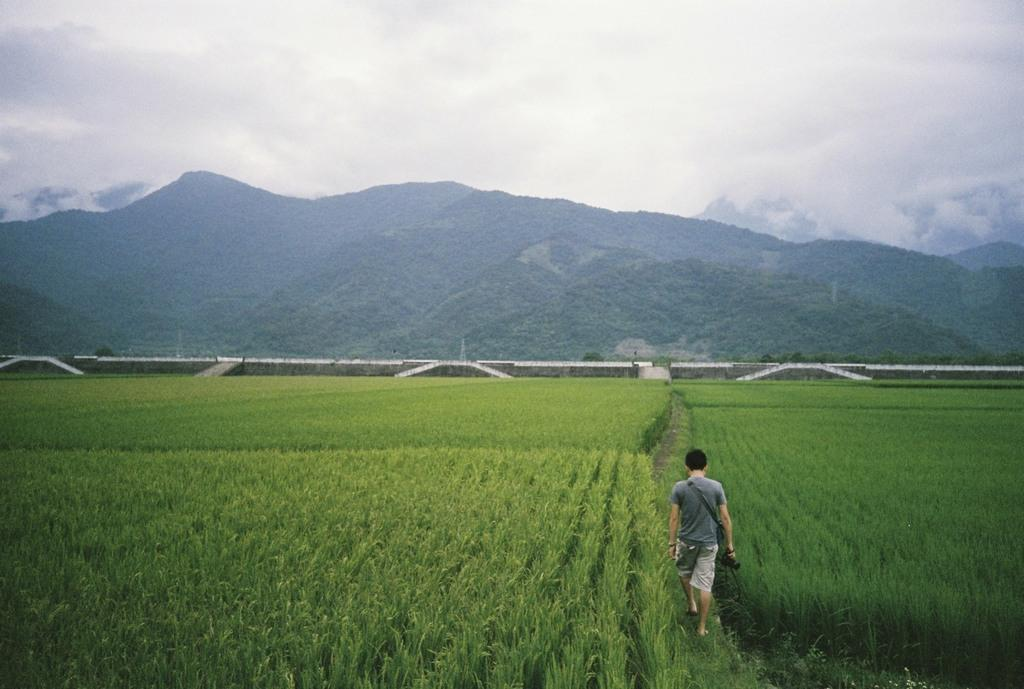What is the main setting of the image? There is a field in the image. What is the person in the image doing? The person is holding a camera and walking. What can be seen in the background of the image? There are hills in the background of the image. What is the color of the background in the image? The background appears to be white. What type of bun is the person eating while walking in the image? There is no bun present in the image; the person is holding a camera and walking. How does the hot temperature affect the person in the image? The temperature is not mentioned in the image, so it cannot be determined how it affects the person. 